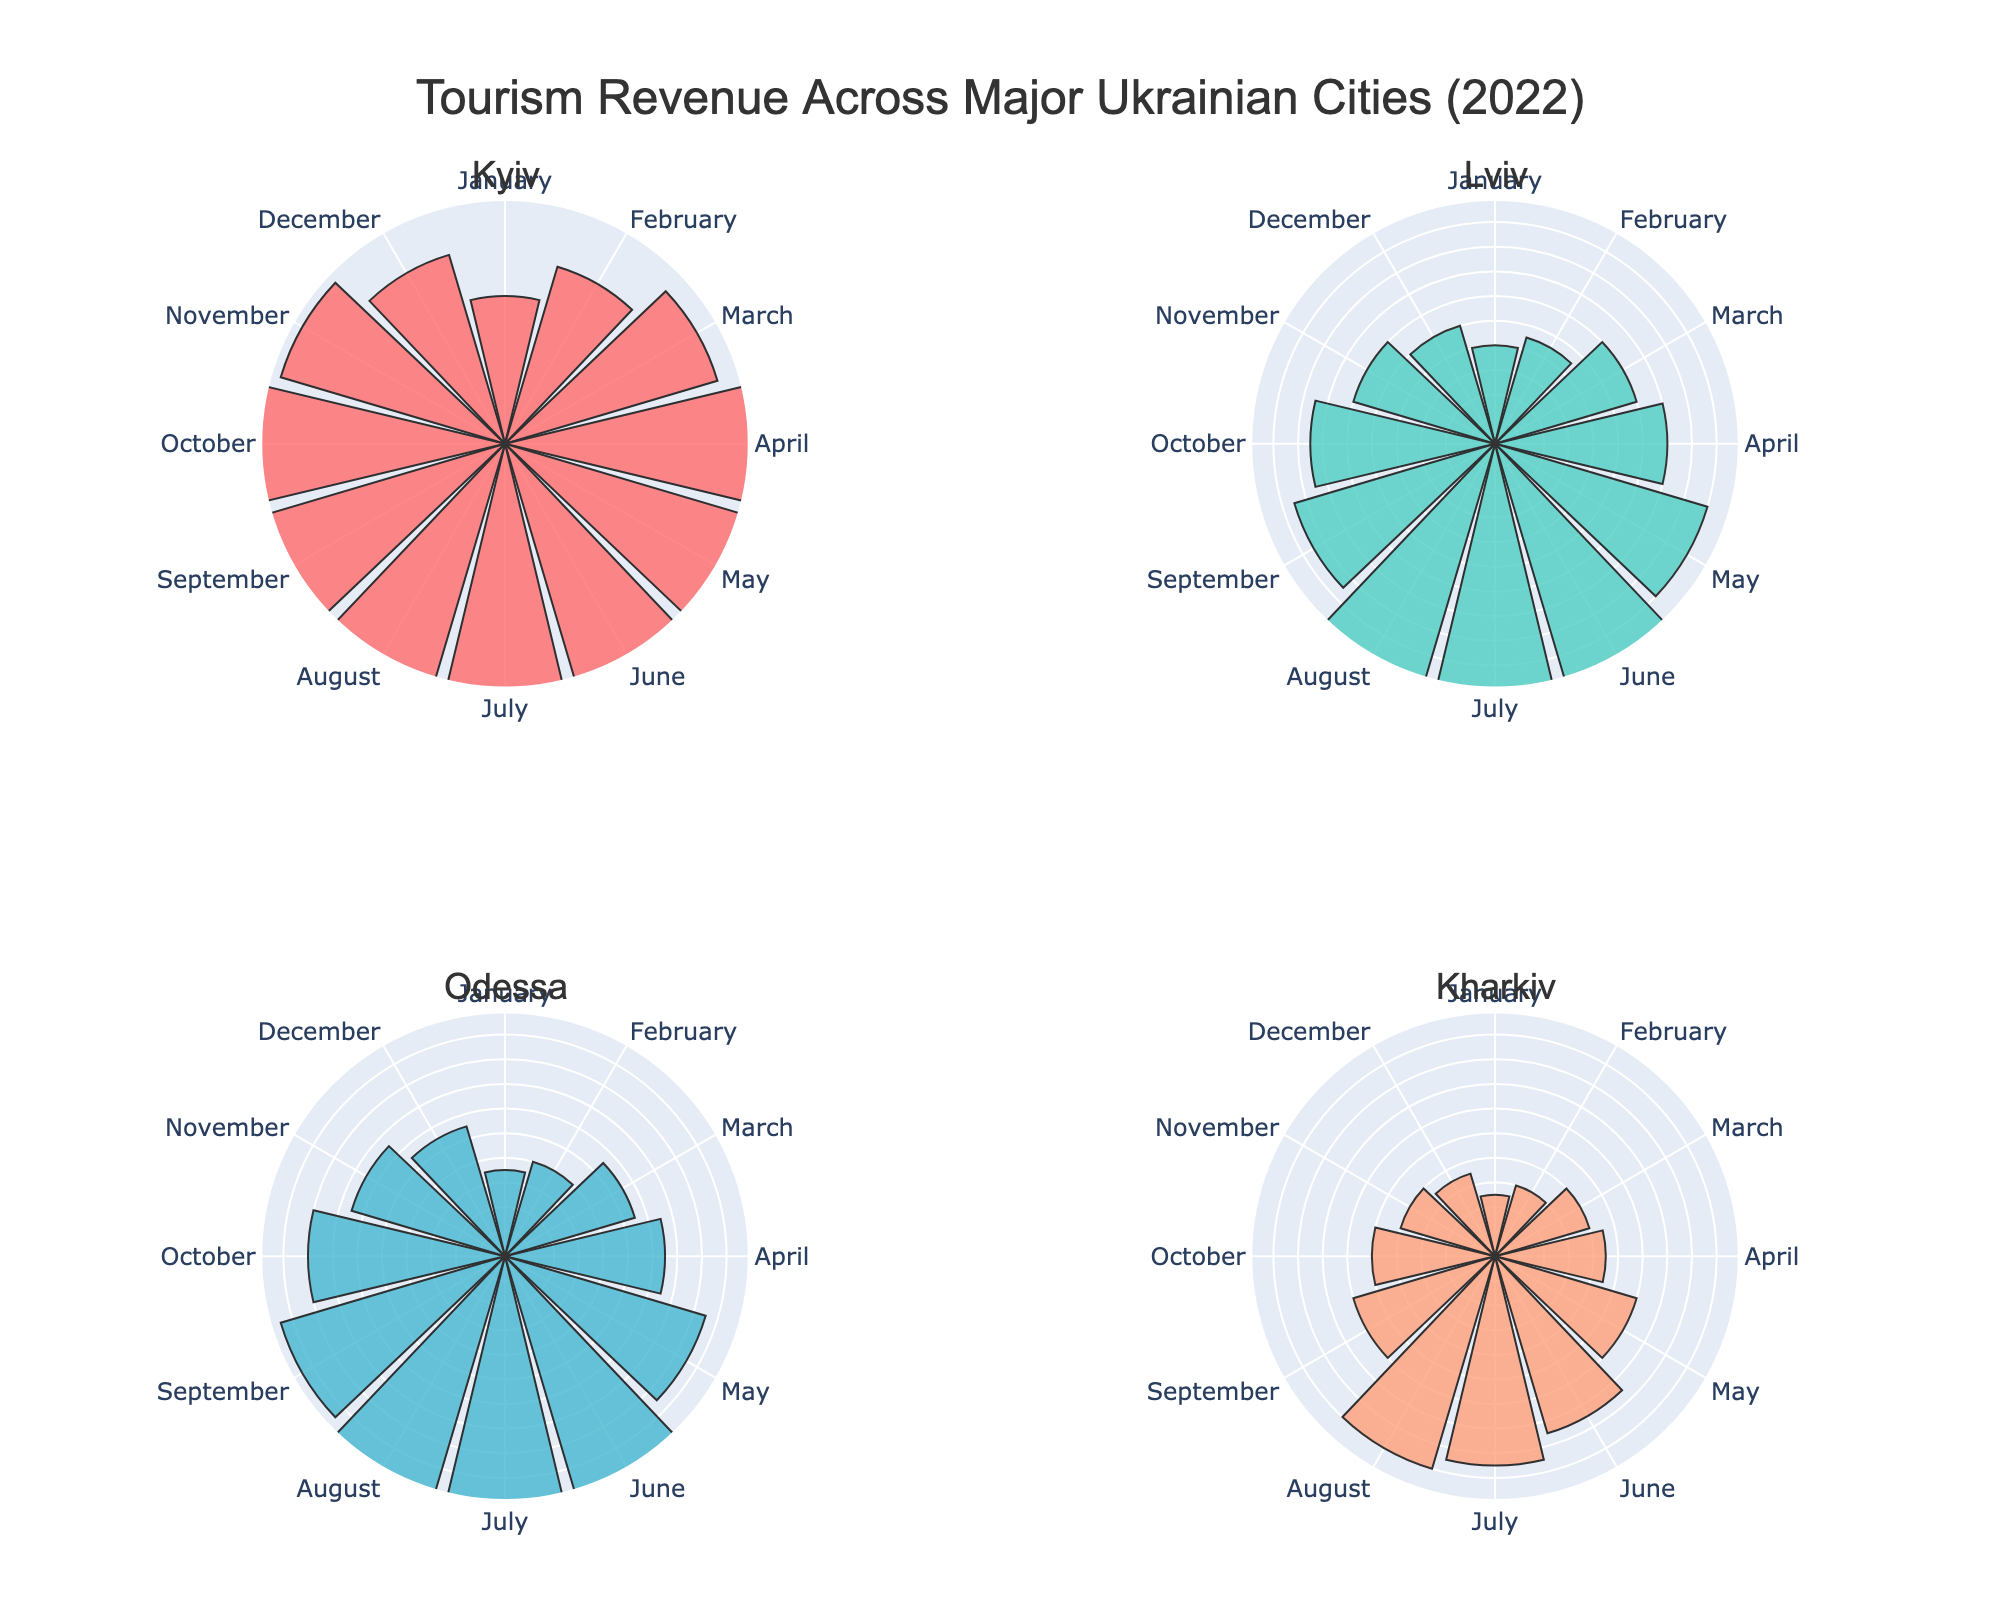What is the title of the plot? The title of the plot is usually displayed at the top center of the figure. In this case, it reads "Tourism Revenue Across Major Ukrainian Cities (2022)"
Answer: Tourism Revenue Across Major Ukrainian Cities (2022) Which city had the highest tourism revenue in August? By examining the bar lengths for August in each subplot, we can see that Kyiv has the longest bar for August.
Answer: Kyiv What is the general trend of tourism revenue in Kyiv throughout the year? The bars represent months from January to December. The revenue in Kyiv increases steadily from January to August, peaking in August, and then decreases towards December.
Answer: Increasing until August, then decreasing What is the difference in tourism revenue between June and December for Lviv? Find the length of the bars corresponding to June and December in Lviv's subplot. June has a revenue of 200, and December has a revenue of 100. The difference is calculated as 200 - 100.
Answer: 100 Which city shows the most noticeable seasonal pattern in tourism revenue? By observing all subplots, we can see that Odessa has a distinct increase in revenue during the summer months (June, July, August), suggesting a strong seasonal pattern.
Answer: Odessa How does the revenue in November compare between Kharkiv and Lviv? For November, look at the bar lengths in subplots for Kharkiv and Lviv. Kharkiv's November revenue is 80, while Lviv's November revenue is 120. Lviv's revenue is higher.
Answer: Lviv's revenue is higher What is the average monthly tourism revenue for Odessa in 2022? Sum all the monthly revenues for Odessa: 70 + 80 + 110 + 130 + 170 + 220 + 280 + 300 + 190 + 160 + 130 + 110 = 1950. Divide by 12 to get the average. 1950 / 12 ≈ 162.5.
Answer: 162.5 What season generally generated the highest revenue in Kharkiv? By grouping months into seasons, observe the bar lengths for Kharkiv. Summer months (June, July, August) have noticeably higher revenues compared to other seasons.
Answer: Summer Which city had the lowest tourism revenue in January? Compare the bar lengths for January across all subplots. Kharkiv has the shortest bar for January with a revenue of 50.
Answer: Kharkiv How much higher is June's revenue in Kyiv compared to Kharkiv? Find the revenue for June for both cities: Kyiv's June revenue is 300, and Kharkiv's June revenue is 150. The difference is calculated as 300 - 150.
Answer: 150 